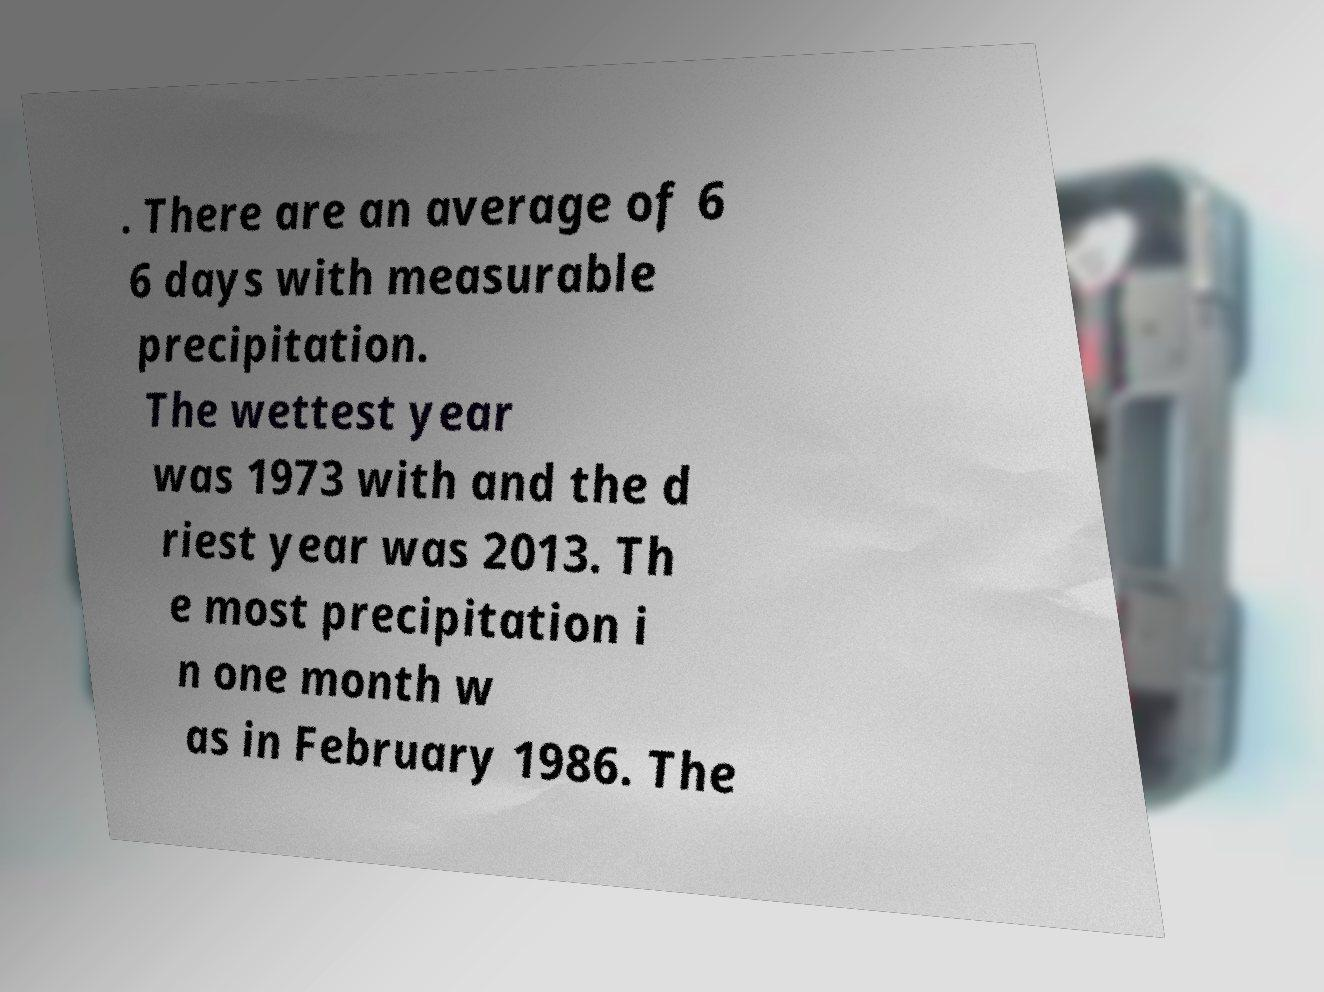Can you read and provide the text displayed in the image?This photo seems to have some interesting text. Can you extract and type it out for me? . There are an average of 6 6 days with measurable precipitation. The wettest year was 1973 with and the d riest year was 2013. Th e most precipitation i n one month w as in February 1986. The 